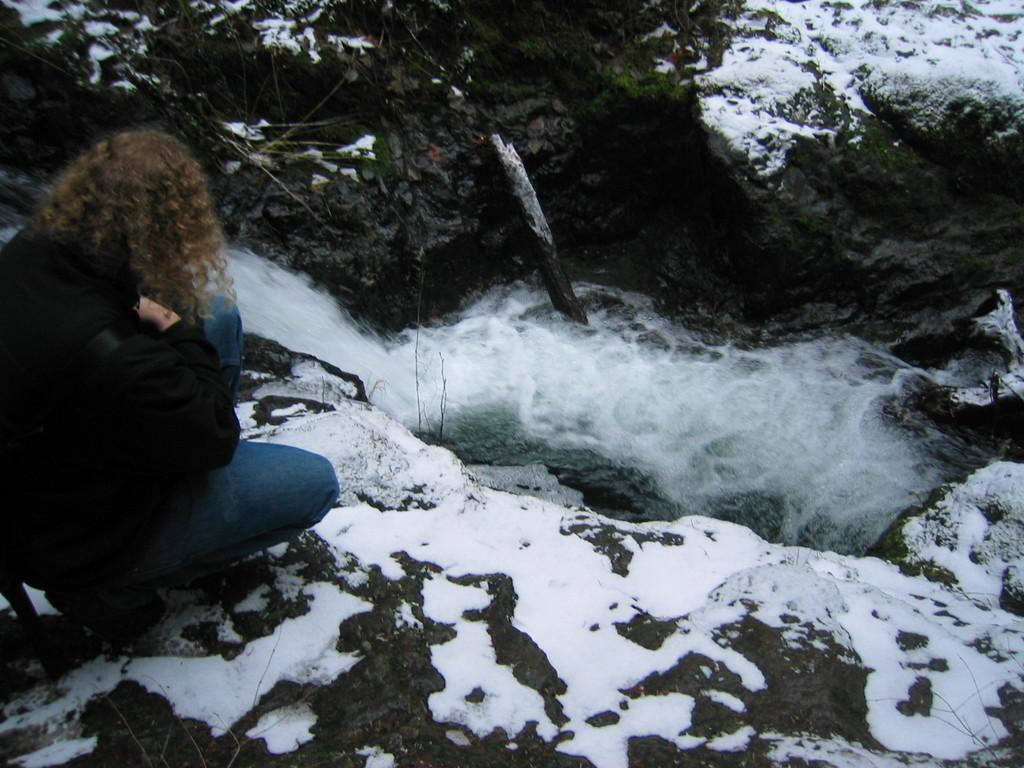What is the person in the image wearing? The person in the image is wearing a black jacket. Where is the person located in the image? The person is on the left side of the image. What is the terrain like in the image? There is snow on the rocks in the image. What natural feature can be seen in the image? There is a waterfall in the image. What type of vegetation is visible in the image? There are plants visible in the image. How many daughters can be seen playing with trucks in the image? There are no daughters or trucks present in the image. Is there a tiger visible in the image? No, there is no tiger present in the image. 